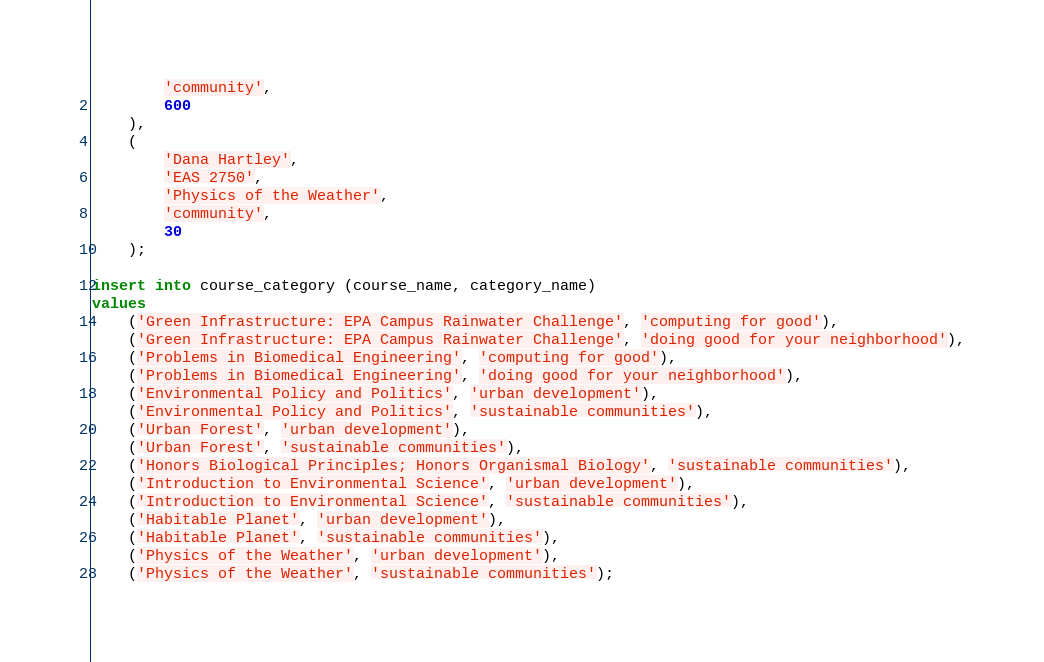Convert code to text. <code><loc_0><loc_0><loc_500><loc_500><_SQL_>        'community',
        600
	),
    (
		'Dana Hartley',
        'EAS 2750',
        'Physics of the Weather',
        'community',
        30
    );

insert into course_category (course_name, category_name)
values
	('Green Infrastructure: EPA Campus Rainwater Challenge', 'computing for good'),
    ('Green Infrastructure: EPA Campus Rainwater Challenge', 'doing good for your neighborhood'),
    ('Problems in Biomedical Engineering', 'computing for good'),
    ('Problems in Biomedical Engineering', 'doing good for your neighborhood'),
    ('Environmental Policy and Politics', 'urban development'),
    ('Environmental Policy and Politics', 'sustainable communities'),
    ('Urban Forest', 'urban development'),
    ('Urban Forest', 'sustainable communities'),
    ('Honors Biological Principles; Honors Organismal Biology', 'sustainable communities'),
    ('Introduction to Environmental Science', 'urban development'),
    ('Introduction to Environmental Science', 'sustainable communities'),
    ('Habitable Planet', 'urban development'),
    ('Habitable Planet', 'sustainable communities'),
    ('Physics of the Weather', 'urban development'),
    ('Physics of the Weather', 'sustainable communities');    </code> 